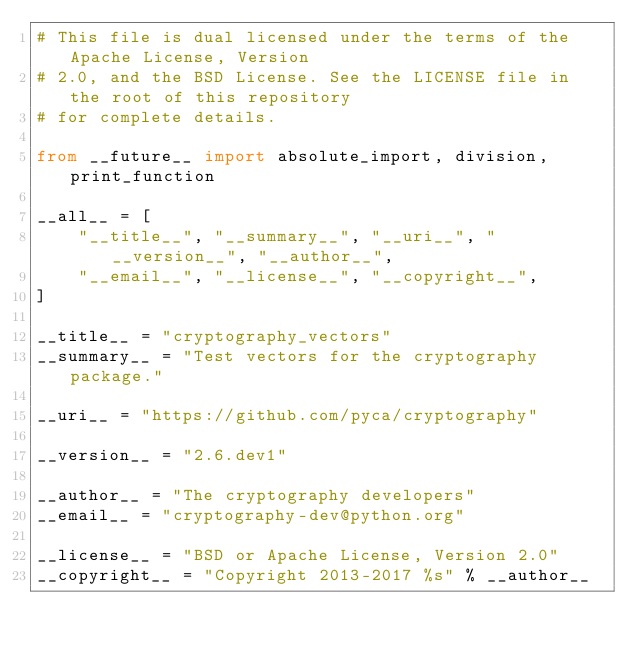<code> <loc_0><loc_0><loc_500><loc_500><_Python_># This file is dual licensed under the terms of the Apache License, Version
# 2.0, and the BSD License. See the LICENSE file in the root of this repository
# for complete details.

from __future__ import absolute_import, division, print_function

__all__ = [
    "__title__", "__summary__", "__uri__", "__version__", "__author__",
    "__email__", "__license__", "__copyright__",
]

__title__ = "cryptography_vectors"
__summary__ = "Test vectors for the cryptography package."

__uri__ = "https://github.com/pyca/cryptography"

__version__ = "2.6.dev1"

__author__ = "The cryptography developers"
__email__ = "cryptography-dev@python.org"

__license__ = "BSD or Apache License, Version 2.0"
__copyright__ = "Copyright 2013-2017 %s" % __author__
</code> 